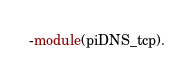<code> <loc_0><loc_0><loc_500><loc_500><_Erlang_>-module(piDNS_tcp).
</code> 